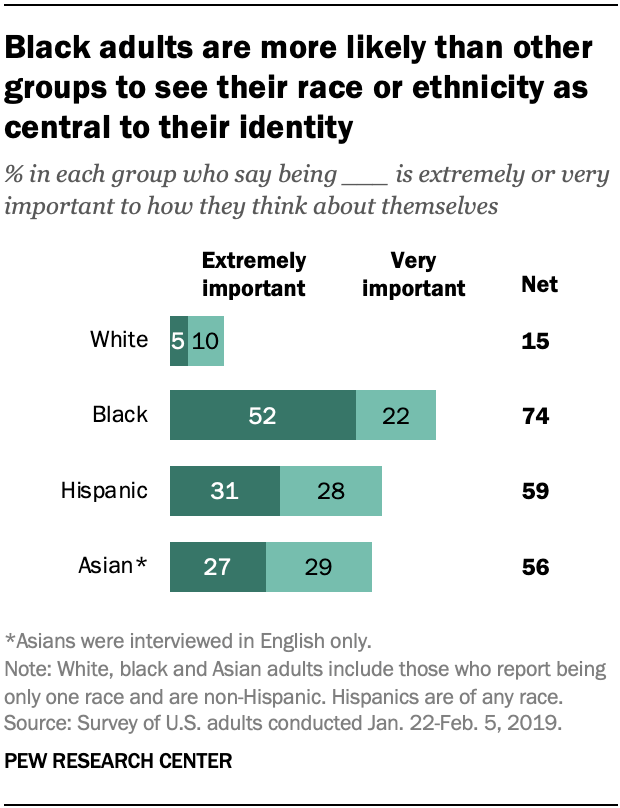List a handful of essential elements in this visual. The percentage of Black people who hold the opinion that it is "Very important" is 22%. The ratio of the two smallest bar (A to B) is 0.043055556... 